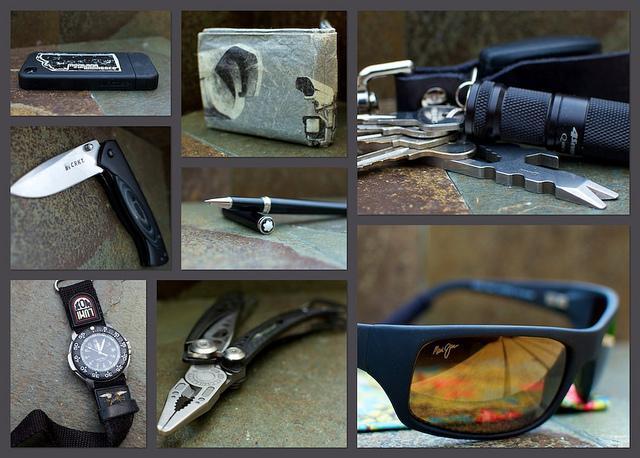How many people are there?
Give a very brief answer. 0. 